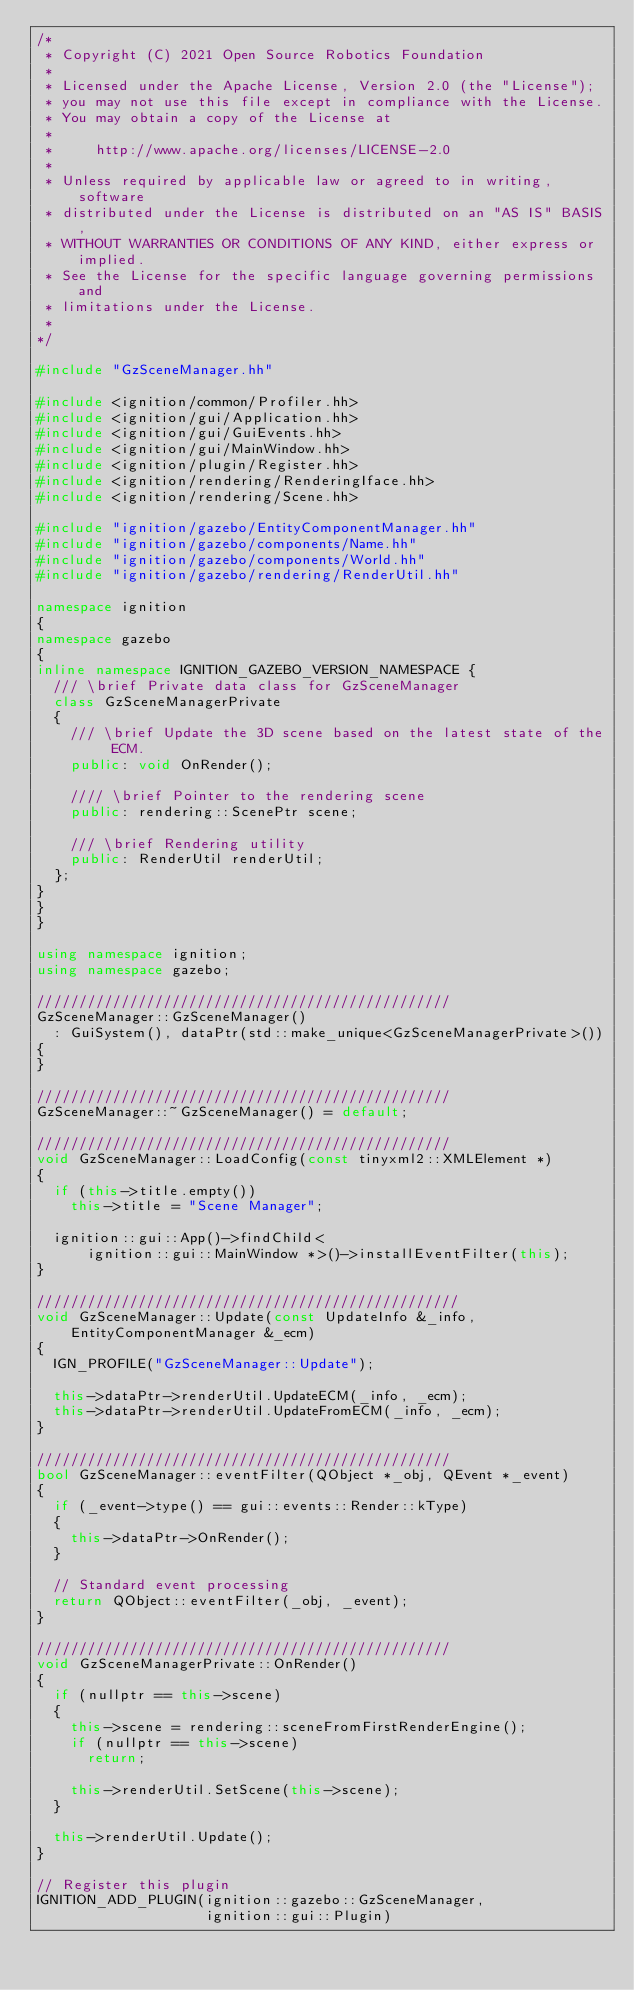Convert code to text. <code><loc_0><loc_0><loc_500><loc_500><_C++_>/*
 * Copyright (C) 2021 Open Source Robotics Foundation
 *
 * Licensed under the Apache License, Version 2.0 (the "License");
 * you may not use this file except in compliance with the License.
 * You may obtain a copy of the License at
 *
 *     http://www.apache.org/licenses/LICENSE-2.0
 *
 * Unless required by applicable law or agreed to in writing, software
 * distributed under the License is distributed on an "AS IS" BASIS,
 * WITHOUT WARRANTIES OR CONDITIONS OF ANY KIND, either express or implied.
 * See the License for the specific language governing permissions and
 * limitations under the License.
 *
*/

#include "GzSceneManager.hh"

#include <ignition/common/Profiler.hh>
#include <ignition/gui/Application.hh>
#include <ignition/gui/GuiEvents.hh>
#include <ignition/gui/MainWindow.hh>
#include <ignition/plugin/Register.hh>
#include <ignition/rendering/RenderingIface.hh>
#include <ignition/rendering/Scene.hh>

#include "ignition/gazebo/EntityComponentManager.hh"
#include "ignition/gazebo/components/Name.hh"
#include "ignition/gazebo/components/World.hh"
#include "ignition/gazebo/rendering/RenderUtil.hh"

namespace ignition
{
namespace gazebo
{
inline namespace IGNITION_GAZEBO_VERSION_NAMESPACE {
  /// \brief Private data class for GzSceneManager
  class GzSceneManagerPrivate
  {
    /// \brief Update the 3D scene based on the latest state of the ECM.
    public: void OnRender();

    //// \brief Pointer to the rendering scene
    public: rendering::ScenePtr scene;

    /// \brief Rendering utility
    public: RenderUtil renderUtil;
  };
}
}
}

using namespace ignition;
using namespace gazebo;

/////////////////////////////////////////////////
GzSceneManager::GzSceneManager()
  : GuiSystem(), dataPtr(std::make_unique<GzSceneManagerPrivate>())
{
}

/////////////////////////////////////////////////
GzSceneManager::~GzSceneManager() = default;

/////////////////////////////////////////////////
void GzSceneManager::LoadConfig(const tinyxml2::XMLElement *)
{
  if (this->title.empty())
    this->title = "Scene Manager";

  ignition::gui::App()->findChild<
      ignition::gui::MainWindow *>()->installEventFilter(this);
}

//////////////////////////////////////////////////
void GzSceneManager::Update(const UpdateInfo &_info,
    EntityComponentManager &_ecm)
{
  IGN_PROFILE("GzSceneManager::Update");

  this->dataPtr->renderUtil.UpdateECM(_info, _ecm);
  this->dataPtr->renderUtil.UpdateFromECM(_info, _ecm);
}

/////////////////////////////////////////////////
bool GzSceneManager::eventFilter(QObject *_obj, QEvent *_event)
{
  if (_event->type() == gui::events::Render::kType)
  {
    this->dataPtr->OnRender();
  }

  // Standard event processing
  return QObject::eventFilter(_obj, _event);
}

/////////////////////////////////////////////////
void GzSceneManagerPrivate::OnRender()
{
  if (nullptr == this->scene)
  {
    this->scene = rendering::sceneFromFirstRenderEngine();
    if (nullptr == this->scene)
      return;

    this->renderUtil.SetScene(this->scene);
  }

  this->renderUtil.Update();
}

// Register this plugin
IGNITION_ADD_PLUGIN(ignition::gazebo::GzSceneManager,
                    ignition::gui::Plugin)
</code> 